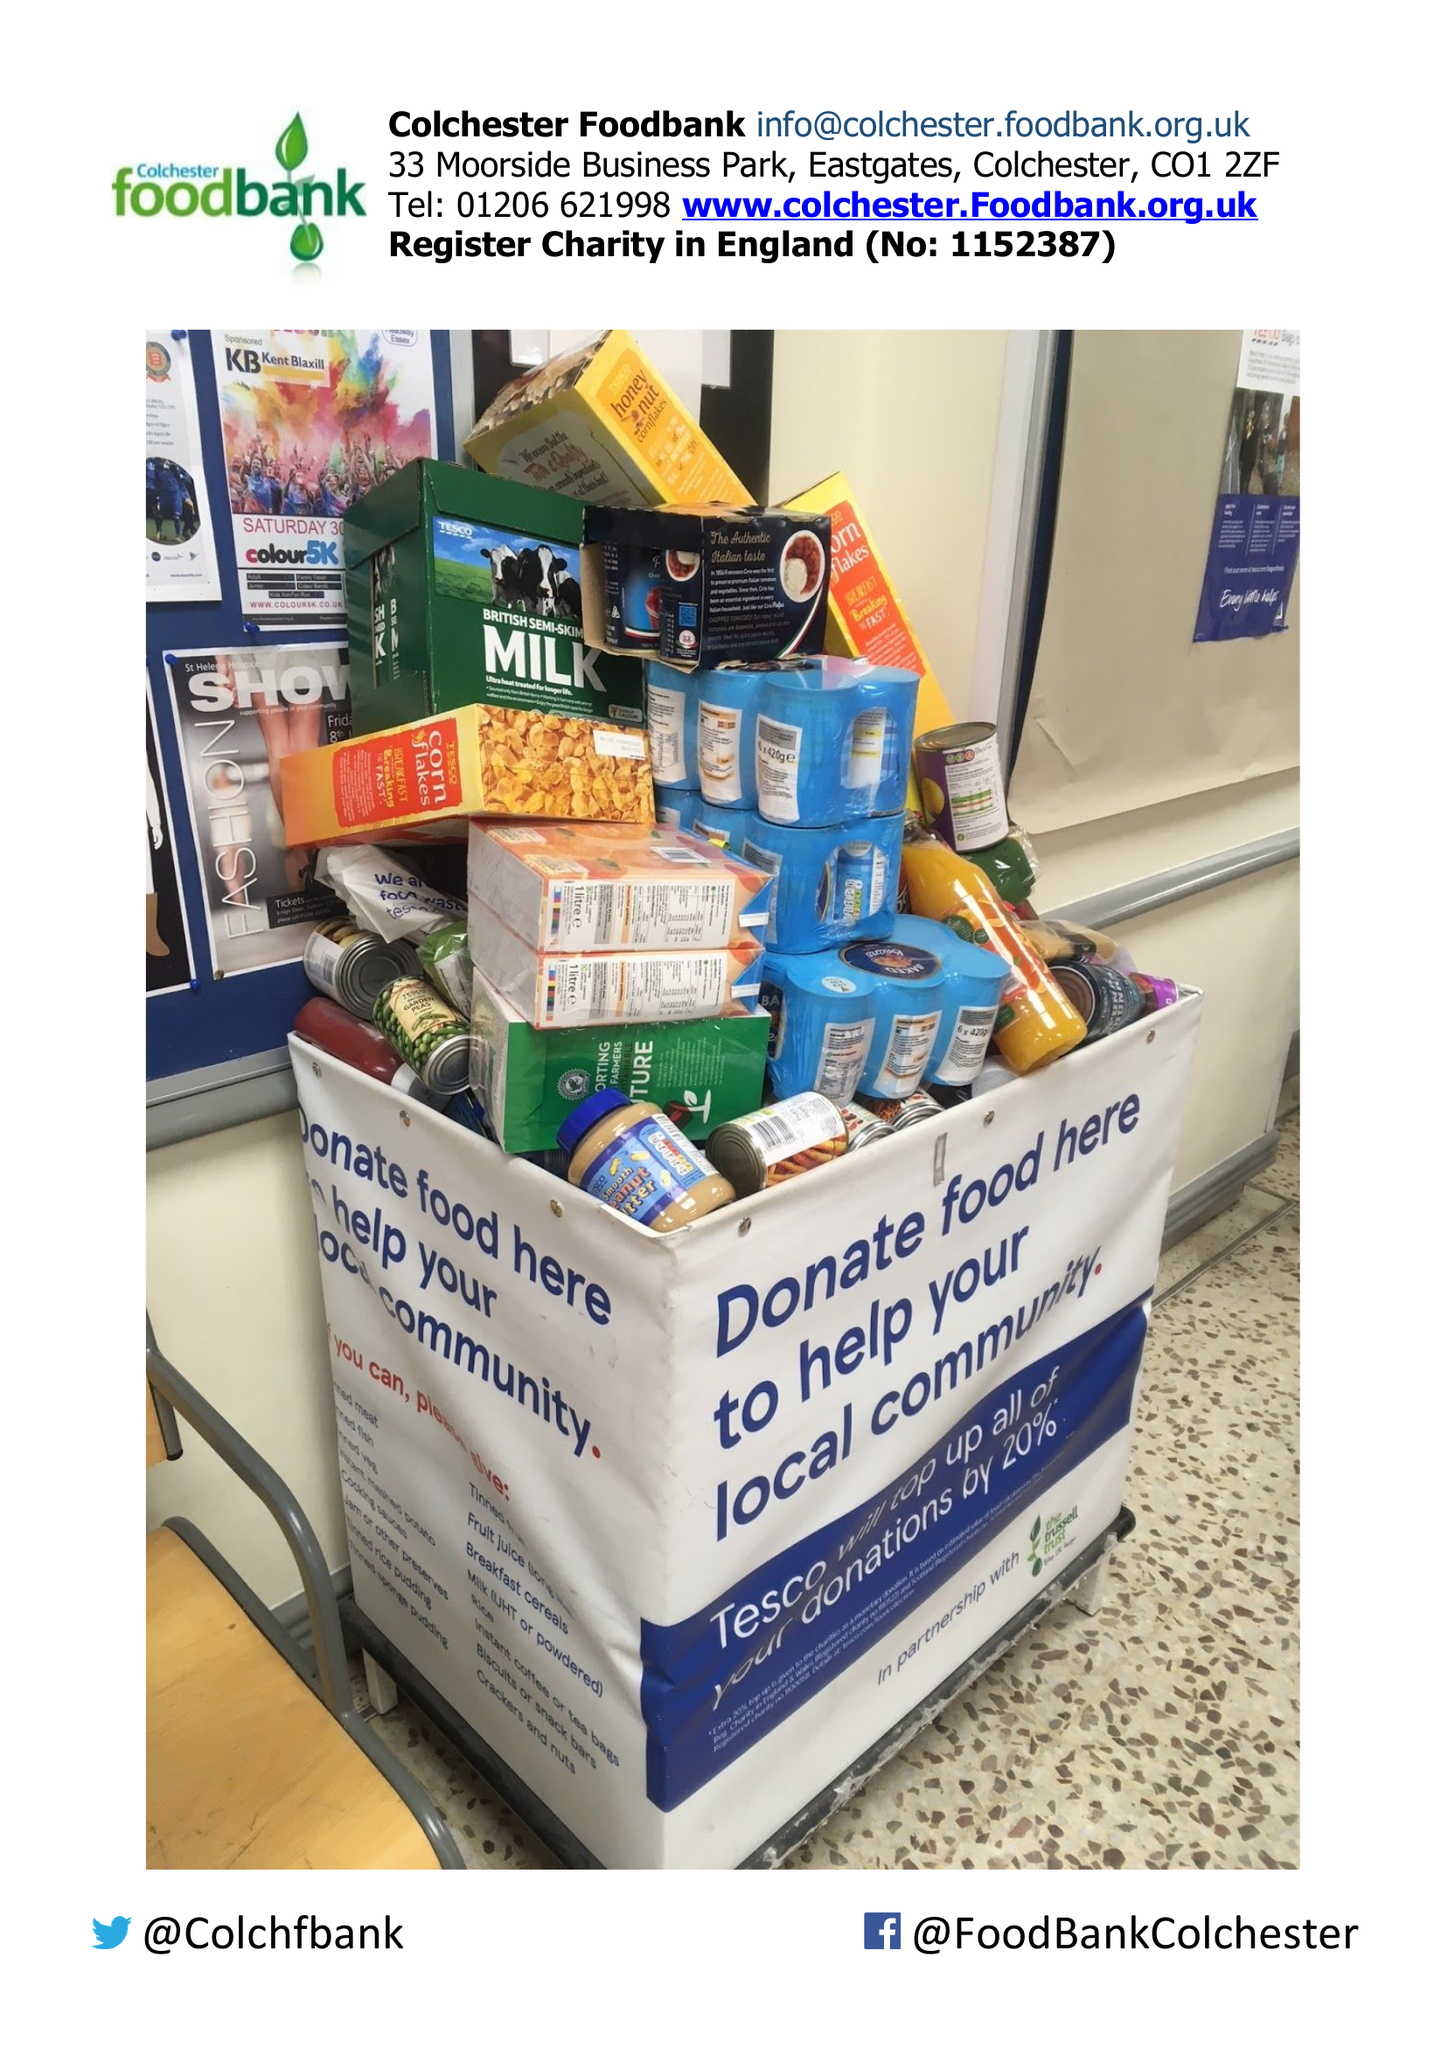What is the value for the report_date?
Answer the question using a single word or phrase. 2017-12-31 